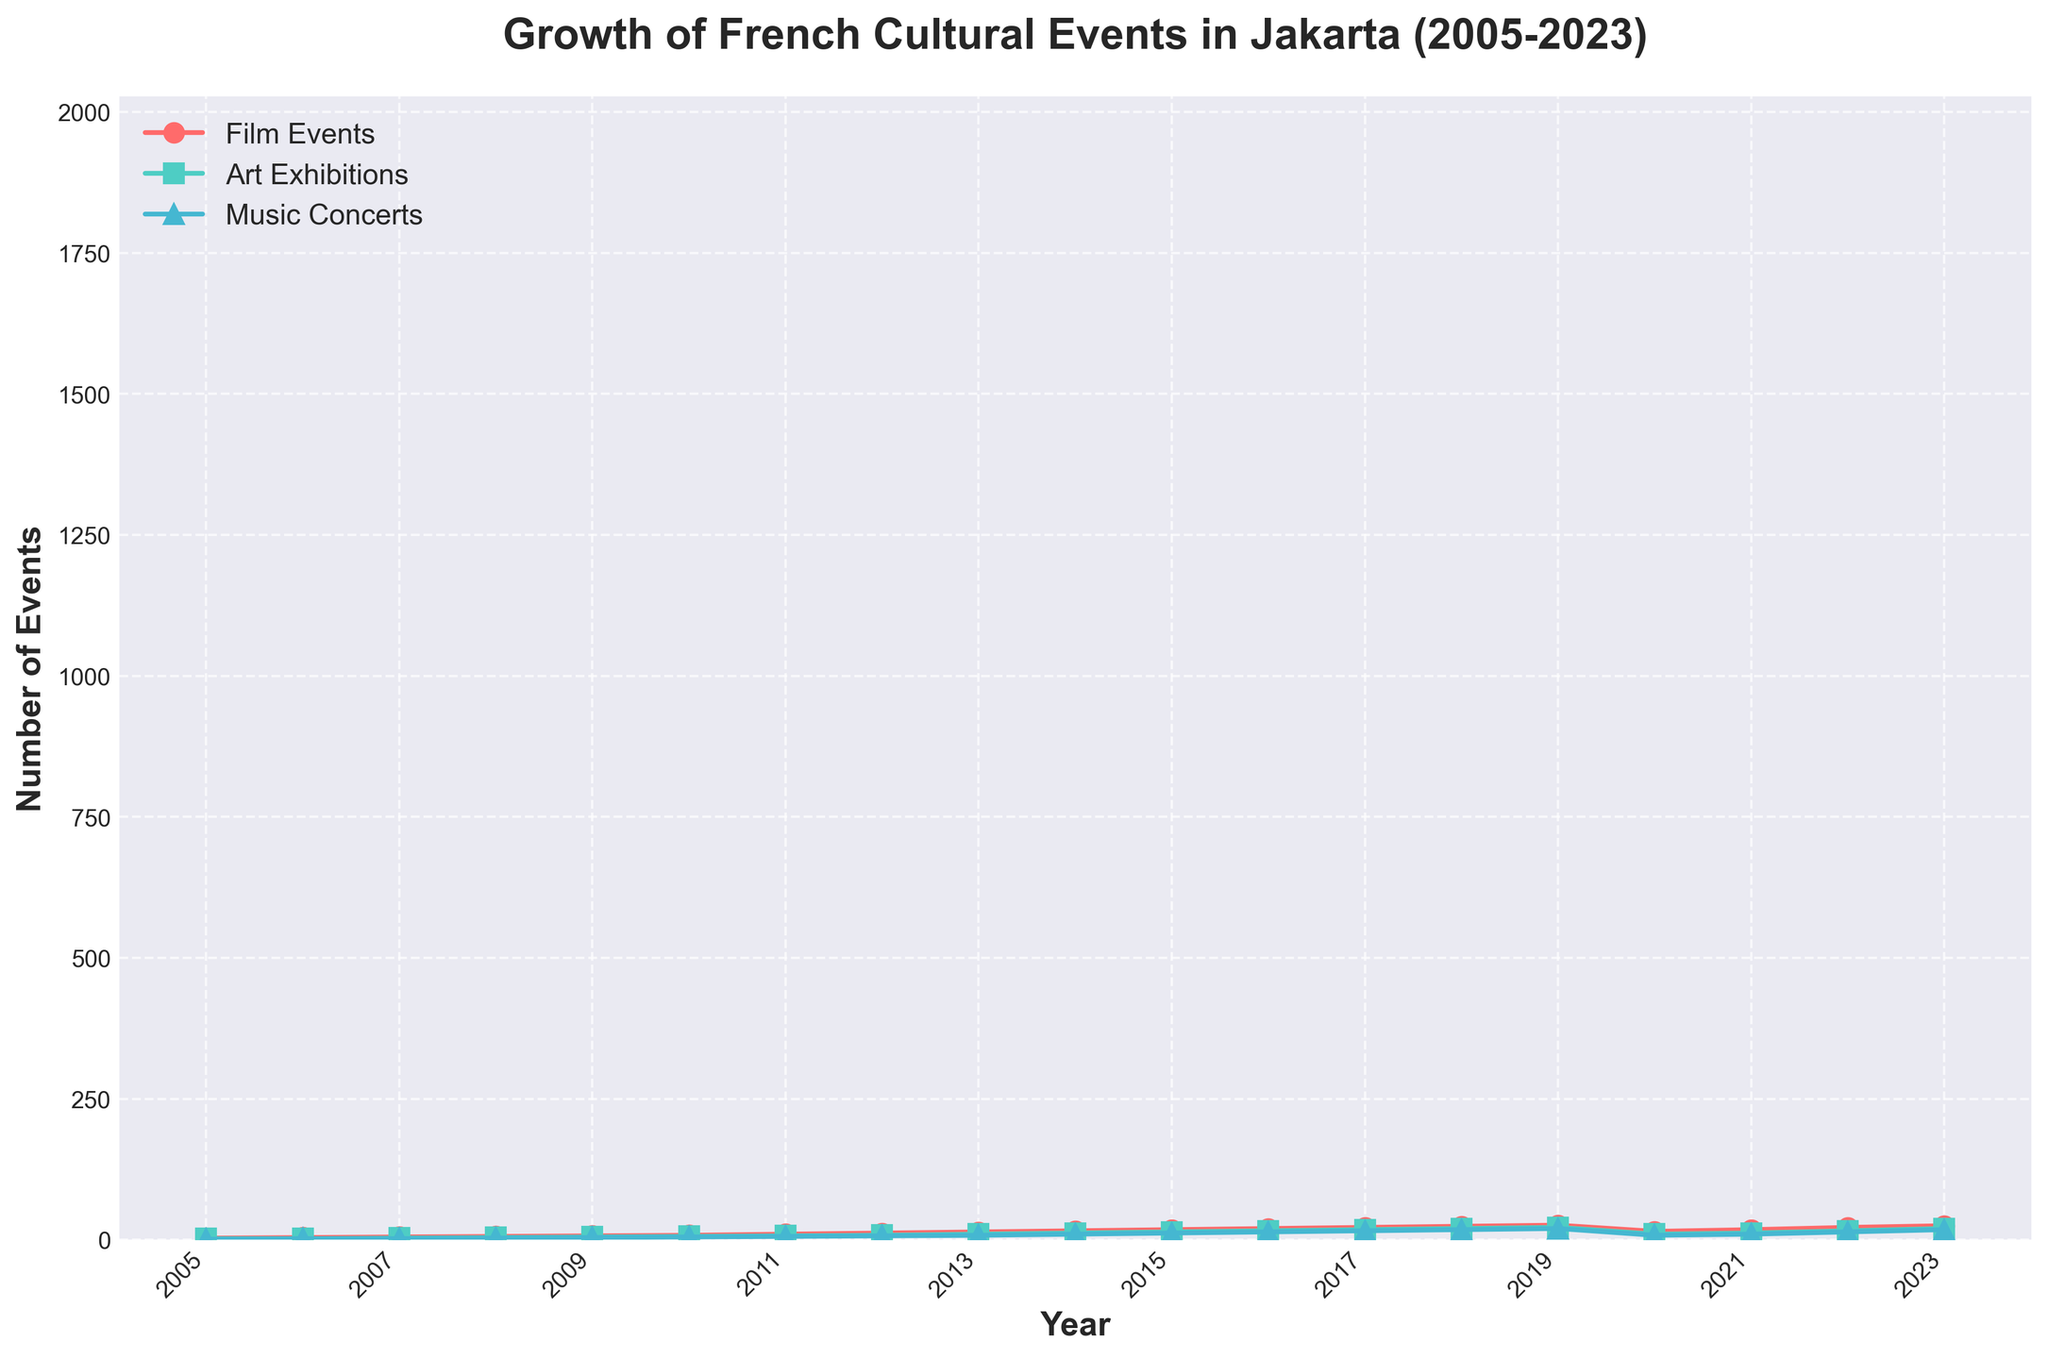What was the total number of Art Exhibitions held between 2005 and 2010? Sum up the number of Art Exhibitions from each year between 2005 and 2010: 2 (2005) + 2 (2006) + 3 (2007) + 4 (2008) + 5 (2009) + 6 (2010) = 22
Answer: 22 What year did Film Events first exceed 20 events? Identify the first year where Film Events were greater than 20. This occurs in 2016 with 20 events, and exceeds it in 2017 with 22 events. Thus, 2017 is the answer.
Answer: 2017 Which type of event had the largest increase in the number of events from 2019 to 2020? Compare the number of events in 2019 and 2020 for each category: Film Events decreased from 26 to 15 (a drop of 11), Art Exhibitions decreased from 22 to 10 (a drop of 12), Music Concerts decreased from 20 to 8 (a drop of 12). The largest drop occurred in Art Exhibitions and Music Concerts, both with a decrease of 12 events.
Answer: Tie between Art Exhibitions and Music Concerts What is the difference in the number of Music Concerts held in 2019 and 2023? Subtract the number of Music Concerts in 2019 from those in 2023: 18 (2023) - 20 (2019) = -2, meaning 2 fewer concerts were held in 2023 compared to 2019.
Answer: -2 In which year did the three types of events (Film, Art, Music) grow linearly without any drop? Identify the continuous increase without any drop for all three categories. The year 2018 shows growth from 2017 and continues into 2019 for all three event types.
Answer: 2018 What was the average number of Film Events held from 2005 to 2015? Sum the number of Film Events from 2005 to 2015, then divide by the number of years: (3+4+5+6+7+8+10+12+14+16+18) = 103, total years = 11, so average is 103/11 = 9.36
Answer: 9.36 Which category had the least number of events in 2011? Compare the number of events for each category in 2011: Film Events = 10, Art Exhibitions = 7, Music Concerts = 6. Music Concerts had the least number of events.
Answer: Music Concerts What is the decade (10 years) with the most significant growth for Film Events? Calculate the growth for Film Events in every 10-year span. From 2005 to 2015: 18-3=15, 2013 to 2023: 25-14=11. The most significant growth (15 events) occurred from 2005 to 2015.
Answer: 2005-2015 What year saw the largest increase in Art Exhibitions? Calculate the year-over-year change for Art Exhibitions and identify the largest: (7-6), (8-7), (10-8), (12-10), (14-12).... The largest year-over-year increase was from 2012 to 2013 with an increase of 2 events (10-8).
Answer: 2013 How many more Film Events were there than Music Concerts in 2022? Subtract the number of Music Concerts from the number of Film Events in 2022: 22 (Film) - 14 (Music) = 8.
Answer: 8 